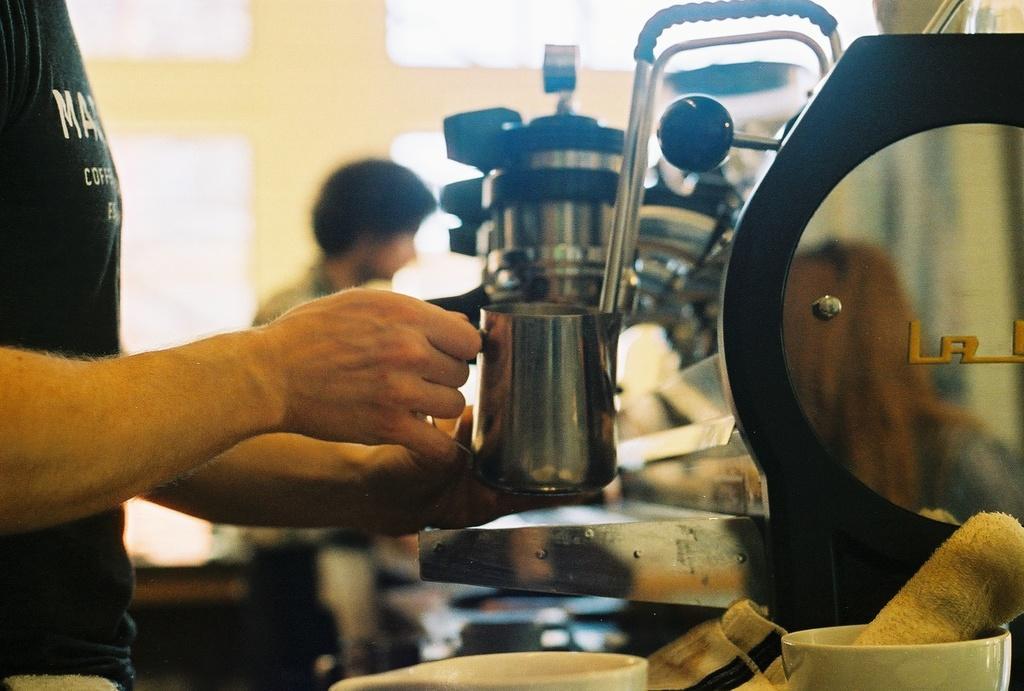In one or two sentences, can you explain what this image depicts? In the image there is a person holding a cup with the hand and beside the cup there is a machine, the background of the machine is blur. 